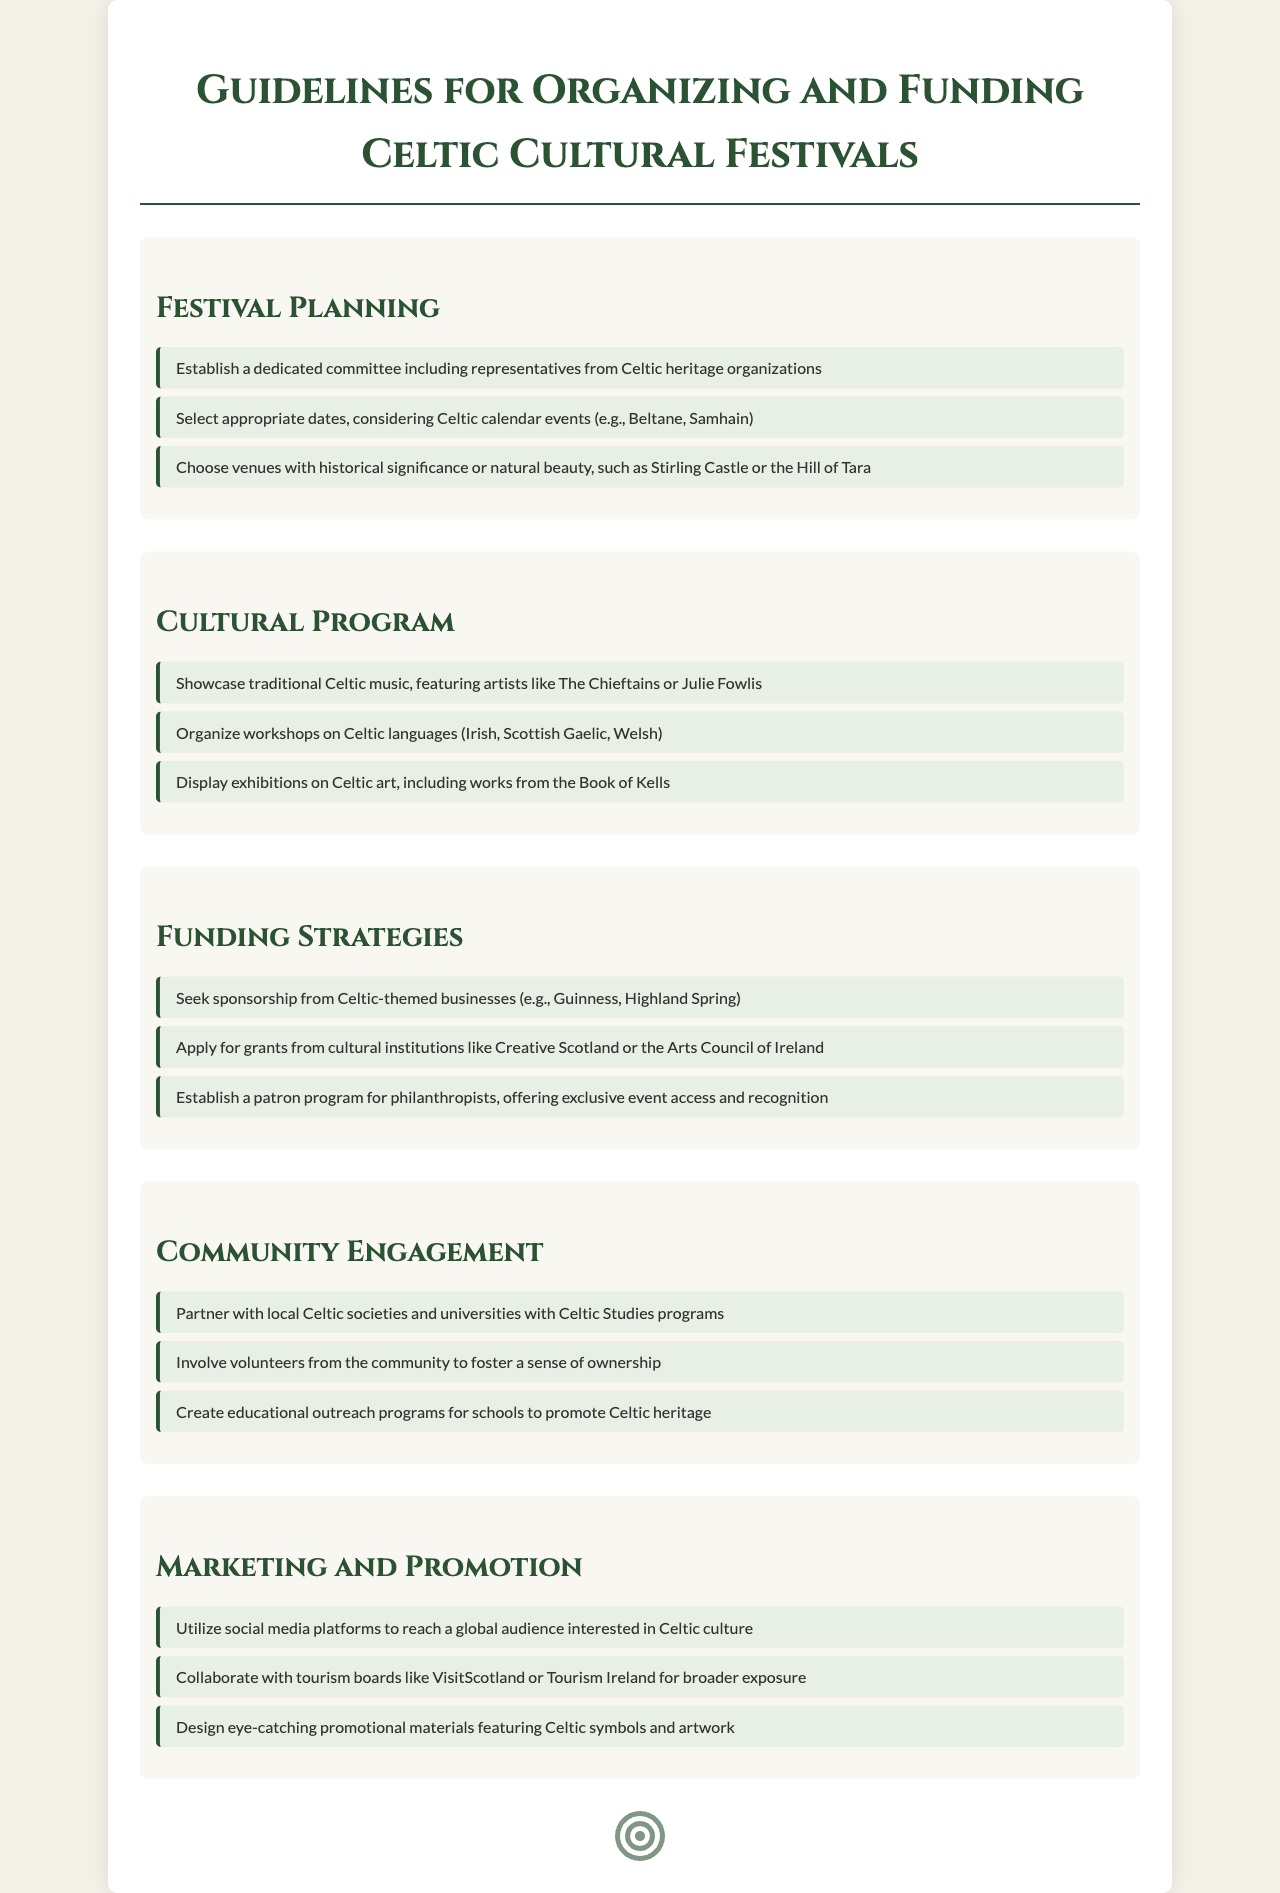What is the title of the document? The title is prominently displayed at the top of the document and states the purpose clearly.
Answer: Guidelines for Organizing and Funding Celtic Cultural Festivals What is one key component of festival planning? The document lists specific items under each section, with bullet points indicating key components.
Answer: Establish a dedicated committee including representatives from Celtic heritage organizations Which event is used as a reference for selecting festival dates? The document mentions Celtic calendar events that should be considered when choosing dates.
Answer: Beltane, Samhain Name one strategy for funding the festivals. The funding strategies section outlines various methods for securing funds for the festivals.
Answer: Seek sponsorship from Celtic-themed businesses What type of community engagement is suggested in the document? The sections are dedicated to different aspects, and one is specifically about community involvement.
Answer: Partner with local Celtic societies and universities with Celtic Studies programs How should marketing efforts be conducted? The marketing and promotion section suggests ways to reach audiences interested in Celtic culture.
Answer: Utilize social media platforms to reach a global audience What is an example of a cultural program activity mentioned? Cultural activities are listed in detail, providing a broad view of what should be included in the program.
Answer: Organize workshops on Celtic languages Who can apply for grants mentioned in the document? This information is specified in the funding strategies section, guiding who can seek financial support.
Answer: Arts Council of Ireland, Creative Scotland 